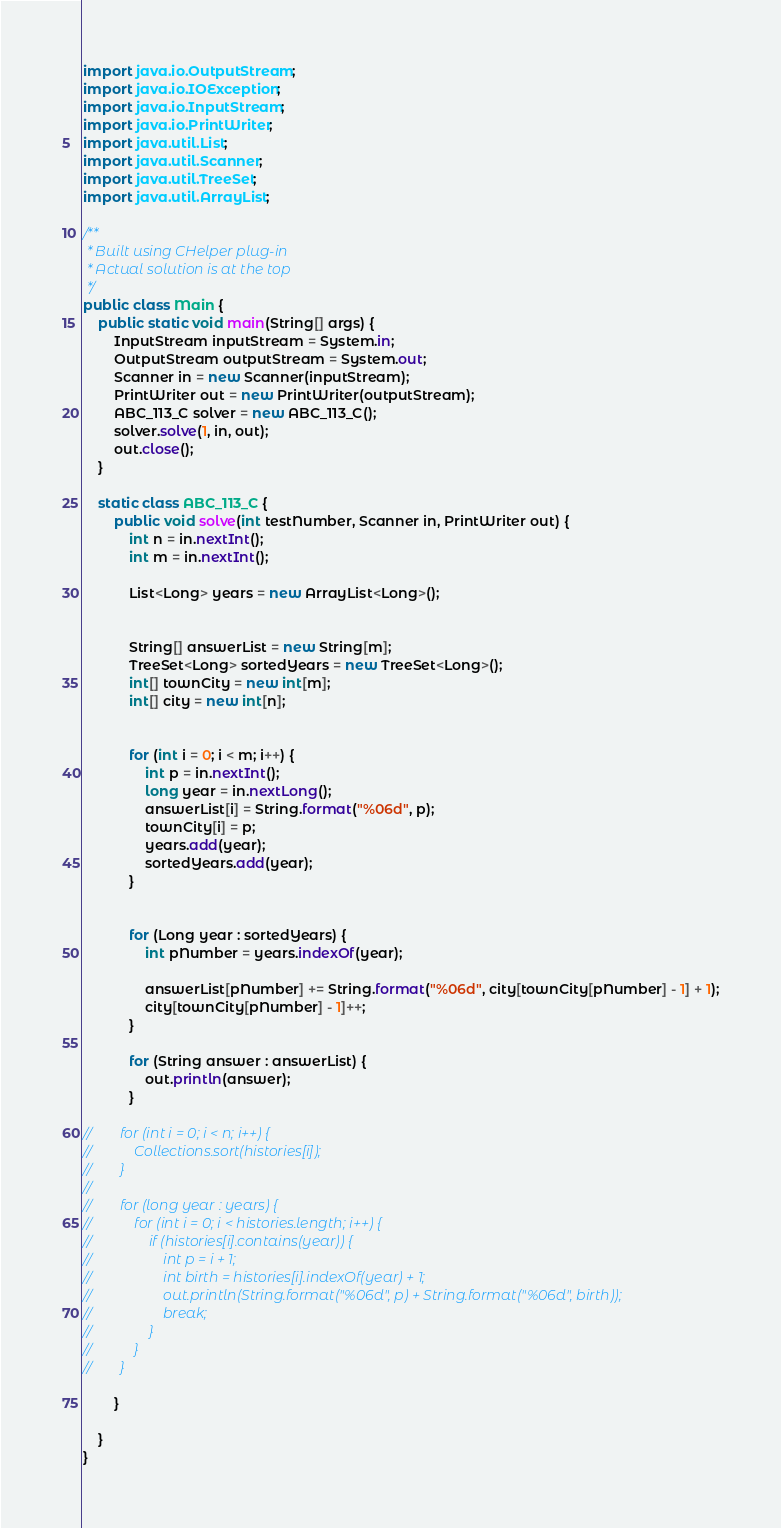Convert code to text. <code><loc_0><loc_0><loc_500><loc_500><_Java_>import java.io.OutputStream;
import java.io.IOException;
import java.io.InputStream;
import java.io.PrintWriter;
import java.util.List;
import java.util.Scanner;
import java.util.TreeSet;
import java.util.ArrayList;

/**
 * Built using CHelper plug-in
 * Actual solution is at the top
 */
public class Main {
    public static void main(String[] args) {
        InputStream inputStream = System.in;
        OutputStream outputStream = System.out;
        Scanner in = new Scanner(inputStream);
        PrintWriter out = new PrintWriter(outputStream);
        ABC_113_C solver = new ABC_113_C();
        solver.solve(1, in, out);
        out.close();
    }

    static class ABC_113_C {
        public void solve(int testNumber, Scanner in, PrintWriter out) {
            int n = in.nextInt();
            int m = in.nextInt();

            List<Long> years = new ArrayList<Long>();


            String[] answerList = new String[m];
            TreeSet<Long> sortedYears = new TreeSet<Long>();
            int[] townCity = new int[m];
            int[] city = new int[n];


            for (int i = 0; i < m; i++) {
                int p = in.nextInt();
                long year = in.nextLong();
                answerList[i] = String.format("%06d", p);
                townCity[i] = p;
                years.add(year);
                sortedYears.add(year);
            }


            for (Long year : sortedYears) {
                int pNumber = years.indexOf(year);

                answerList[pNumber] += String.format("%06d", city[townCity[pNumber] - 1] + 1);
                city[townCity[pNumber] - 1]++;
            }

            for (String answer : answerList) {
                out.println(answer);
            }

//        for (int i = 0; i < n; i++) {
//            Collections.sort(histories[i]);
//        }
//
//        for (long year : years) {
//            for (int i = 0; i < histories.length; i++) {
//                if (histories[i].contains(year)) {
//                    int p = i + 1;
//                    int birth = histories[i].indexOf(year) + 1;
//                    out.println(String.format("%06d", p) + String.format("%06d", birth));
//                    break;
//                }
//            }
//        }

        }

    }
}

</code> 